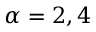<formula> <loc_0><loc_0><loc_500><loc_500>\alpha = 2 , 4</formula> 